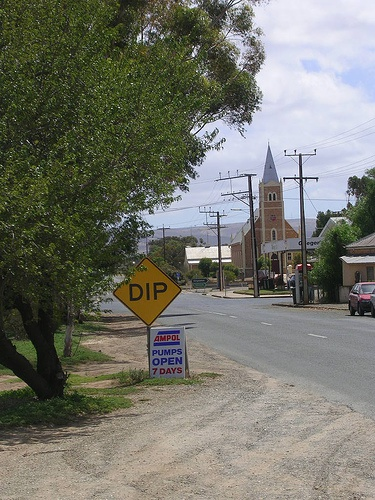Describe the objects in this image and their specific colors. I can see car in black, gray, and darkgray tones and car in black, gray, and darkgray tones in this image. 